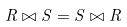Convert formula to latex. <formula><loc_0><loc_0><loc_500><loc_500>R \bowtie S = S \bowtie R</formula> 